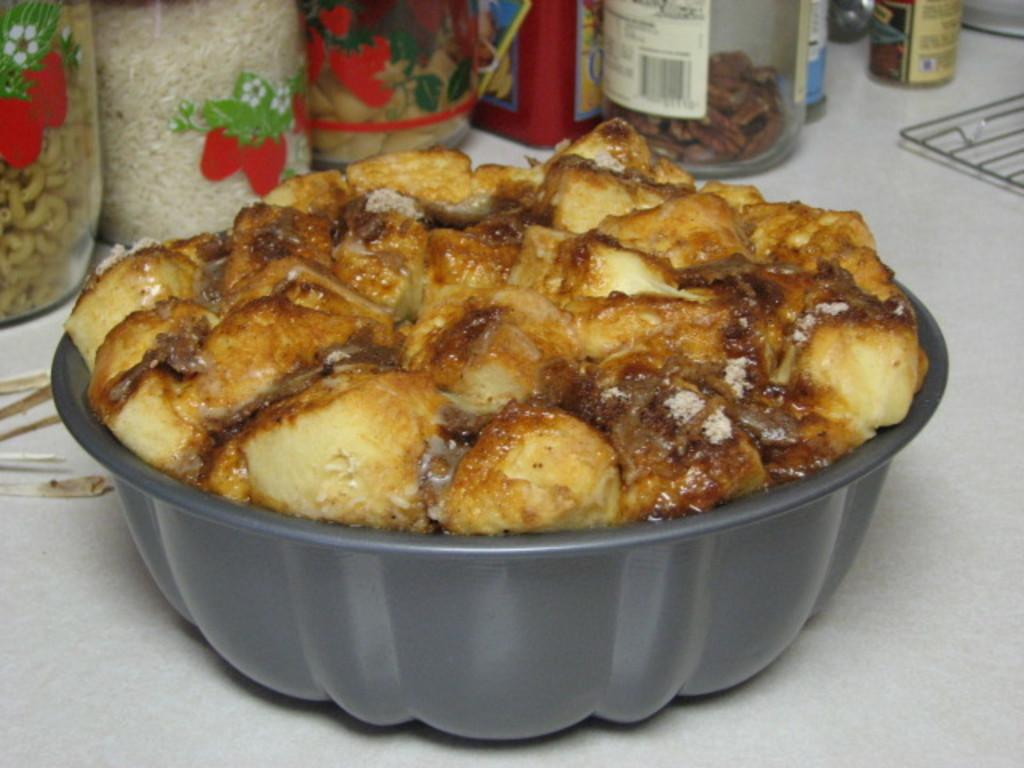What piece of furniture is present in the image? There is a table in the image. What is placed on the table? There is a bowl on the table. What is inside the bowl? There is a food item in the bowl. What can be seen in the background of the image? There are bottles in the background of the image. Are there any food items in the bottles? Yes, there is a food item in at least one of the bottles. What type of fowl can be seen flying around the table in the image? There are no birds or fowl present in the image. How many centimeters tall is the food item in the bowl? The height of the food item in the bowl cannot be determined from the image alone. 